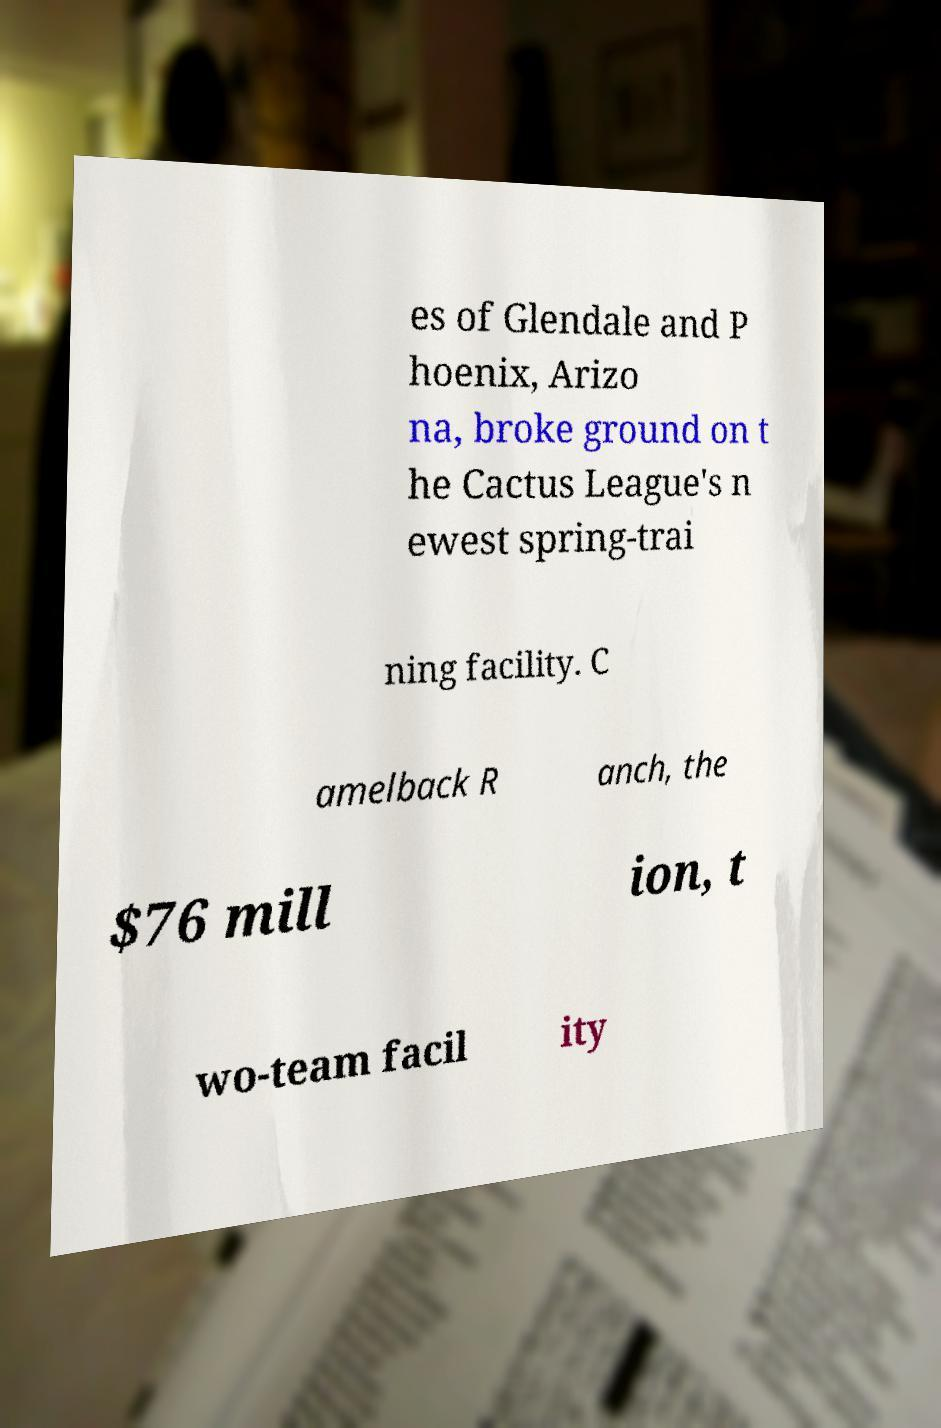Can you accurately transcribe the text from the provided image for me? es of Glendale and P hoenix, Arizo na, broke ground on t he Cactus League's n ewest spring-trai ning facility. C amelback R anch, the $76 mill ion, t wo-team facil ity 